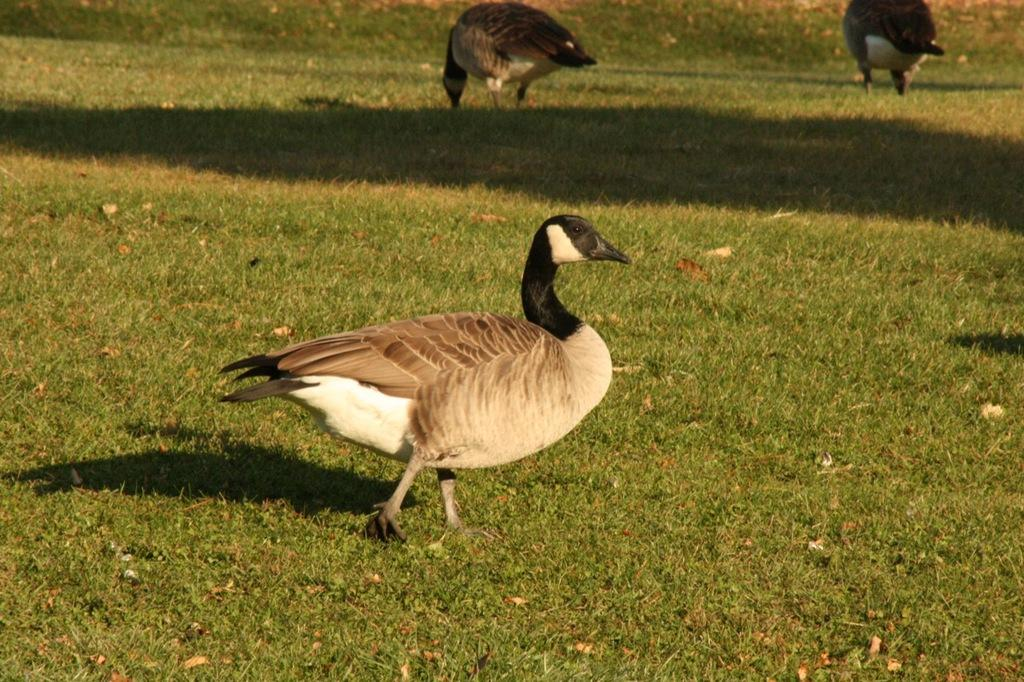What can be seen in the foreground of the picture? In the foreground of the picture, there are dry leaves, grass, and a duck. Can you describe the vegetation in the foreground? The vegetation in the foreground consists of dry leaves and grass. What is present in both the foreground and background of the picture? Grass can be seen in both the foreground and background of the picture. How many ducks are visible in the picture? There is one duck in the foreground and multiple ducks in the background. What type of church can be seen in the background of the picture? There is no church present in the background of the picture; it features grass and multiple ducks. How does the judge interact with the ducks in the picture? There is no judge present in the picture; it only features ducks and vegetation. 